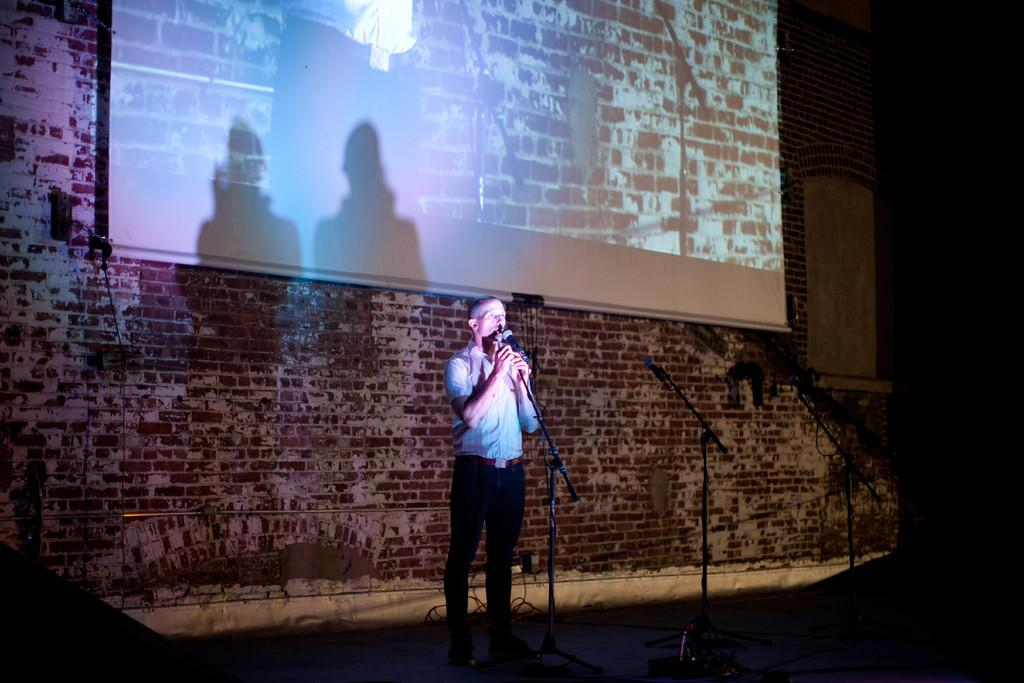What can be seen in the foreground of the picture? In the foreground of the picture, there are stands, a microphone, and a person. What is the purpose of the microphone in the image? The microphone is likely used for amplifying sound during a presentation or event. What is located at the top of the image? There is a projector screen at the top of the image. What type of structure is visible in the middle of the image? There is a brick wall in the middle of the image. What architectural feature can be seen towards the right side of the image? There is a window towards the right side of the image. Can you tell me how many rabbits are sitting on the brick wall in the image? There are no rabbits present in the image; it features a brick wall and other elements related to a presentation or event. What type of bone is visible on the projector screen in the image? There is no bone present on the projector screen in the image; it is a blank screen waiting to display content. 